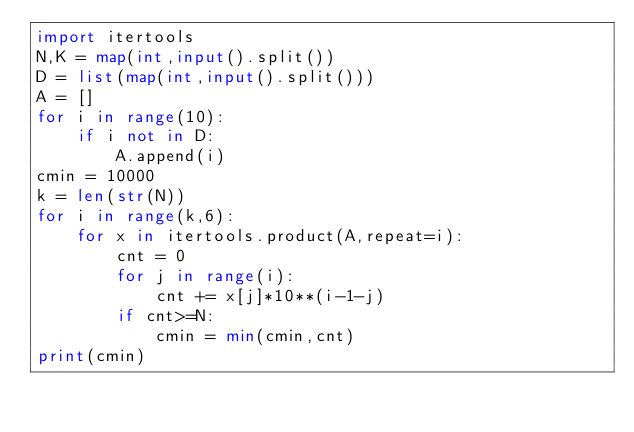<code> <loc_0><loc_0><loc_500><loc_500><_Python_>import itertools
N,K = map(int,input().split())
D = list(map(int,input().split()))
A = []
for i in range(10):
    if i not in D:
        A.append(i)
cmin = 10000
k = len(str(N))
for i in range(k,6):
    for x in itertools.product(A,repeat=i):
        cnt = 0
        for j in range(i):
            cnt += x[j]*10**(i-1-j)
        if cnt>=N:
            cmin = min(cmin,cnt)
print(cmin)</code> 